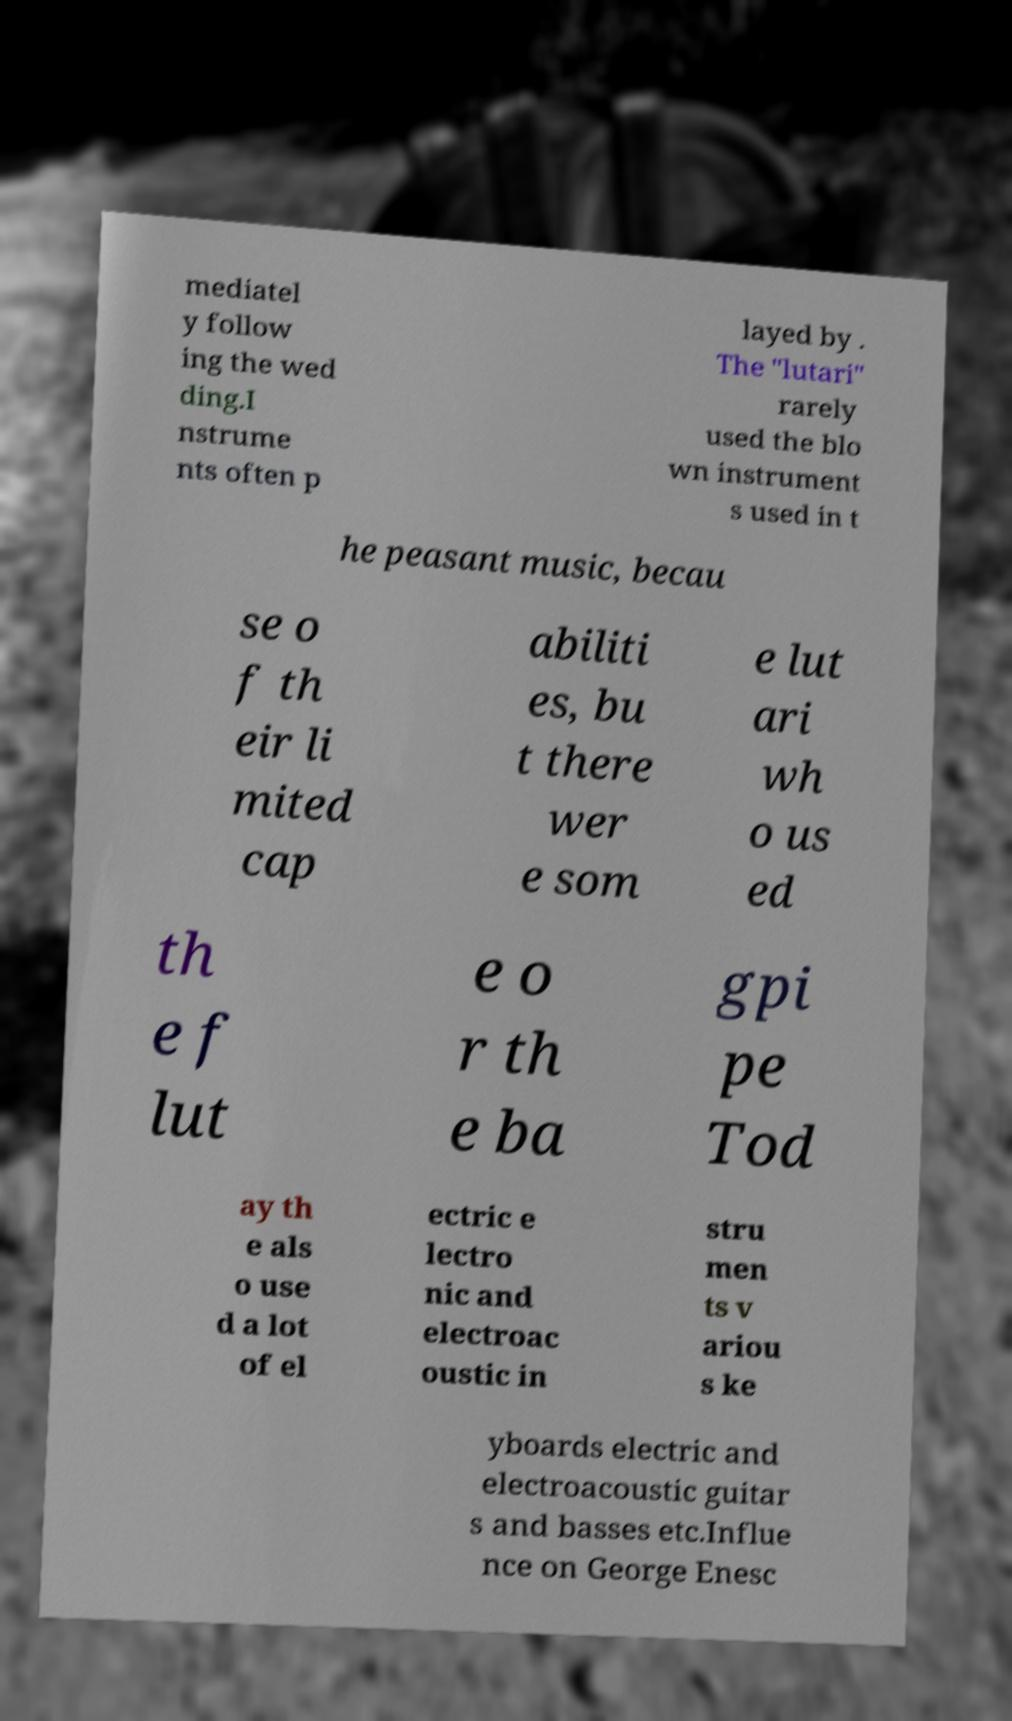Can you read and provide the text displayed in the image?This photo seems to have some interesting text. Can you extract and type it out for me? mediatel y follow ing the wed ding.I nstrume nts often p layed by . The "lutari" rarely used the blo wn instrument s used in t he peasant music, becau se o f th eir li mited cap abiliti es, bu t there wer e som e lut ari wh o us ed th e f lut e o r th e ba gpi pe Tod ay th e als o use d a lot of el ectric e lectro nic and electroac oustic in stru men ts v ariou s ke yboards electric and electroacoustic guitar s and basses etc.Influe nce on George Enesc 